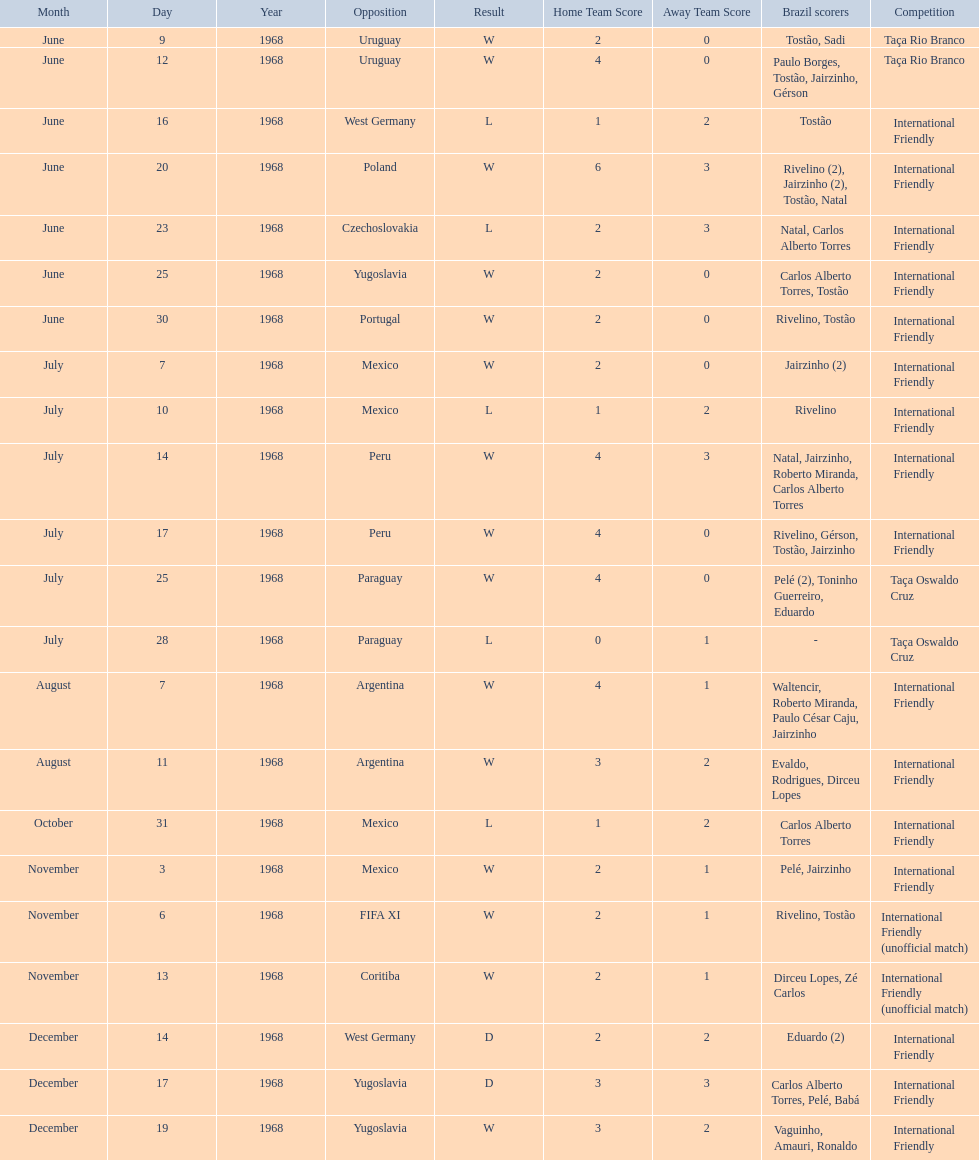Name the first competition ever played by brazil. Taça Rio Branco. 